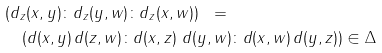<formula> <loc_0><loc_0><loc_500><loc_500>& ( d _ { z } ( x , y ) \colon d _ { z } ( y , w ) \colon d _ { z } ( x , w ) ) \ \ = \\ & \quad ( d ( x , y ) \, d ( z , w ) \colon d ( x , z ) \ d ( y , w ) \colon d ( x , w ) \, d ( y , z ) ) \in \Delta</formula> 